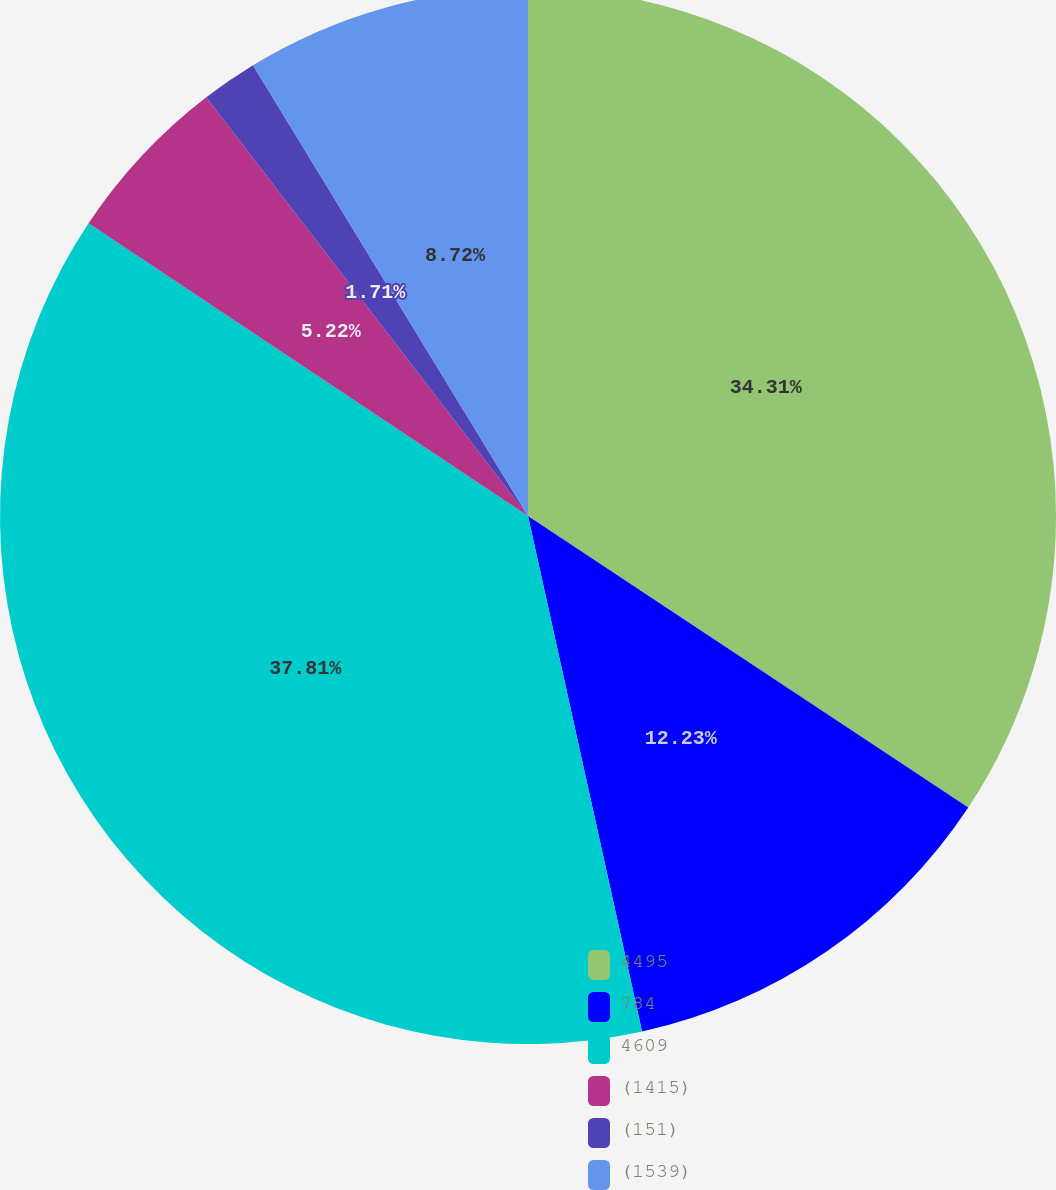<chart> <loc_0><loc_0><loc_500><loc_500><pie_chart><fcel>4495<fcel>784<fcel>4609<fcel>(1415)<fcel>(151)<fcel>(1539)<nl><fcel>34.31%<fcel>12.23%<fcel>37.82%<fcel>5.22%<fcel>1.71%<fcel>8.72%<nl></chart> 